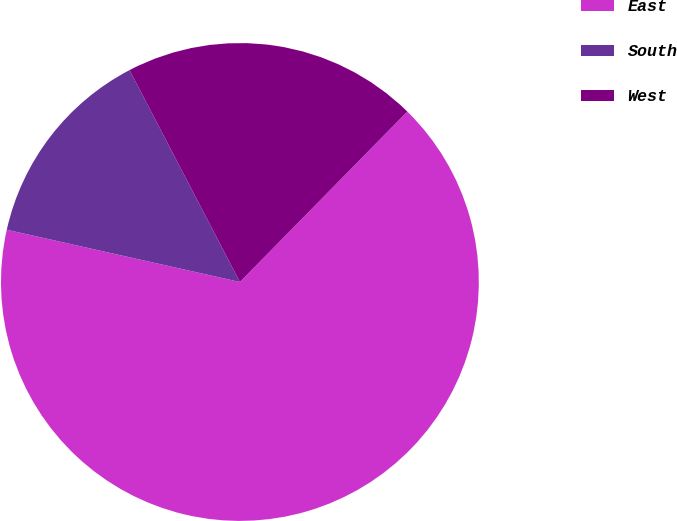Convert chart to OTSL. <chart><loc_0><loc_0><loc_500><loc_500><pie_chart><fcel>East<fcel>South<fcel>West<nl><fcel>66.15%<fcel>13.85%<fcel>20.0%<nl></chart> 